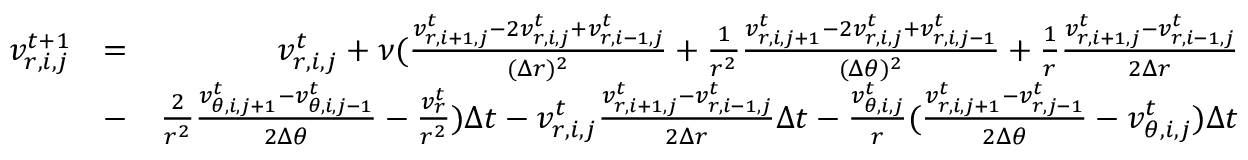<formula> <loc_0><loc_0><loc_500><loc_500>\begin{array} { r l r } { v _ { r , i , j } ^ { t + 1 } } & { = } & { v _ { r , i , j } ^ { t } + \nu ( \frac { v _ { r , i + 1 , j } ^ { t } - 2 v _ { r , i , j } ^ { t } + v _ { r , i - 1 , j } ^ { t } } { ( \Delta r ) ^ { 2 } } + \frac { 1 } { r ^ { 2 } } \frac { v _ { r , i , j + 1 } ^ { t } - 2 v _ { r , i , j } ^ { t } + v _ { r , i , j - 1 } ^ { t } } { ( \Delta \theta ) ^ { 2 } } + \frac { 1 } { r } \frac { v _ { r , i + 1 , j } ^ { t } - v _ { r , i - 1 , j } ^ { t } } { 2 \Delta r } } \\ & { - } & { \frac { 2 } { r ^ { 2 } } \frac { v _ { \theta , i , j + 1 } ^ { t } - v _ { \theta , i , j - 1 } ^ { t } } { 2 \Delta \theta } - \frac { v _ { r } ^ { t } } { r ^ { 2 } } ) \Delta t - v _ { r , i , j } ^ { t } \frac { v _ { r , i + 1 , j } ^ { t } - v _ { r , i - 1 , j } ^ { t } } { 2 \Delta r } \Delta t - \frac { v _ { \theta , i , j } ^ { t } } { r } ( \frac { v _ { r , i , j + 1 } ^ { t } - v _ { r , j - 1 } ^ { t } } { 2 \Delta \theta } - v _ { \theta , i , j } ^ { t } ) \Delta t } \end{array}</formula> 